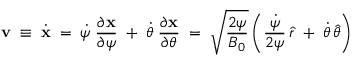<formula> <loc_0><loc_0><loc_500><loc_500>{ v } \, \equiv \, \dot { x } \, = \, \dot { \psi } \, \frac { \partial x } { \partial \psi } \, + \, \dot { \theta } \, \frac { \partial x } { \partial \theta } \, = \, \sqrt { \frac { 2 \psi } { B _ { 0 } } } \left ( \frac { \dot { \psi } } { 2 \psi } \, \widehat { r } \, + \, \dot { \theta } \, \widehat { \theta } \right )</formula> 